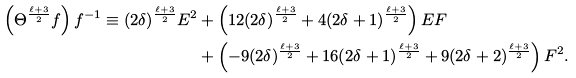<formula> <loc_0><loc_0><loc_500><loc_500>\left ( \Theta ^ { \frac { \ell + 3 } { 2 } } f \right ) f ^ { - 1 } \equiv ( 2 \delta ) ^ { \frac { \ell + 3 } { 2 } } E ^ { 2 } & + \left ( 1 2 ( 2 \delta ) ^ { \frac { \ell + 3 } { 2 } } + 4 ( 2 \delta + 1 ) ^ { \frac { \ell + 3 } { 2 } } \right ) E F \\ & + \left ( - 9 ( 2 \delta ) ^ { \frac { \ell + 3 } { 2 } } + 1 6 ( 2 \delta + 1 ) ^ { \frac { \ell + 3 } { 2 } } + 9 ( 2 \delta + 2 ) ^ { \frac { \ell + 3 } { 2 } } \right ) F ^ { 2 } .</formula> 